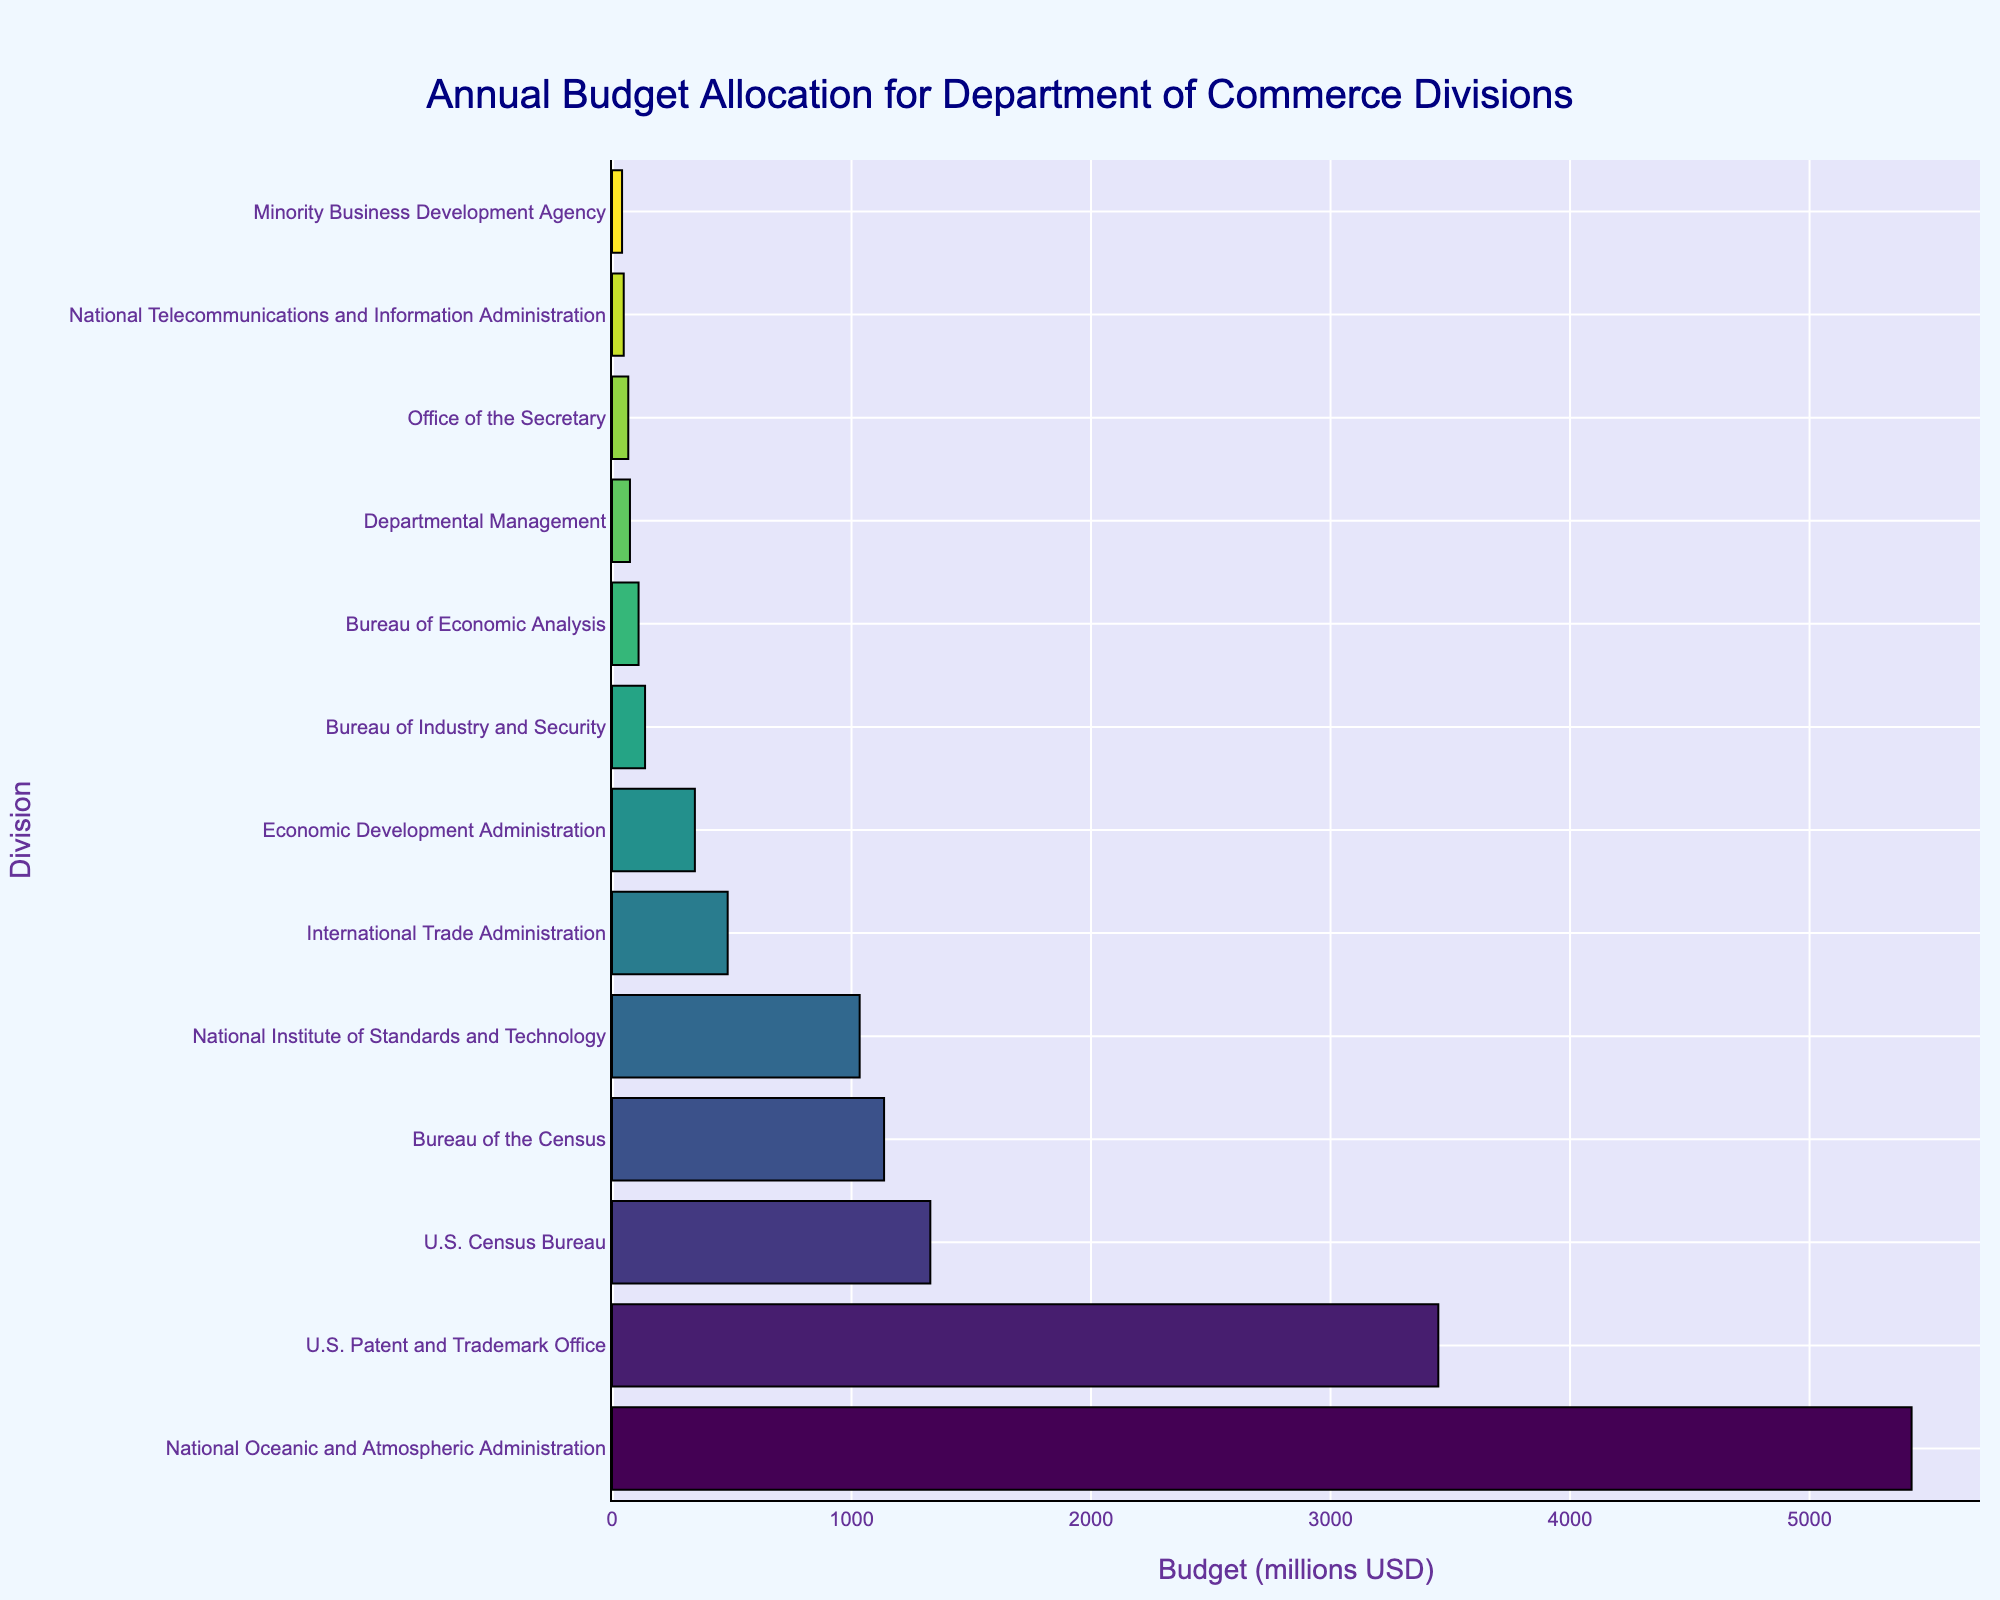Which Division has the highest budget allocation? The Division with the highest budget allocation is the one with the longest bar in the chart. From the bar chart, the National Oceanic and Atmospheric Administration has the longest bar.
Answer: National Oceanic and Atmospheric Administration Which Division has the lowest budget allocation? The Division with the lowest budget allocation has the shortest bar in the chart. From the bar chart, the Minority Business Development Agency has the shortest bar.
Answer: Minority Business Development Agency What is the total budget allocation for the top three Divisions? To find the total budget allocation for the top three Divisions, we need to sum their budget values. The top three Divisions are the National Oceanic and Atmospheric Administration ($5426 million), U.S. Patent and Trademark Office ($3450 million), and U.S. Census Bureau ($1329 million). Therefore, the total is 5426 + 3450 + 1329 = 10205 million USD.
Answer: 10205 million USD How much more budget does the U.S. Patent and Trademark Office have compared to the International Trade Administration? To find how much more budget one Division has compared to another, we subtract the smaller budget from the larger budget. The U.S. Patent and Trademark Office has a budget of $3450 million and the International Trade Administration has a budget of $483 million. Thus, 3450 - 483 = 2967 million USD.
Answer: 2967 million USD What is the average budget allocation of all the Divisions combined? To find the average budget allocation, sum the budgets of all Divisions and divide by the number of Divisions. The total budget allocation is 13199 million USD (sum of all the budgets in the list). There are 13 Divisions, so the average budget is 13199 / 13 ≈ 1015.31 million USD.
Answer: 1015.31 million USD Which Division receives a budget closest to the average budget allocation? First, determine the average budget allocation (1015.31 million USD). Then find the Division with the budget closest to this value. The National Institute of Standards and Technology has a budget of $1034 million, which is closest to the average.
Answer: National Institute of Standards and Technology Is the budget allocation for the U.S. Census Bureau greater than twice the budget of the Bureau of Industry and Security? Double the budget of the Bureau of Industry and Security is 2 * 138 = 276 million USD. The U.S. Census Bureau's budget is $1329 million, which is greater than 276 million USD.
Answer: Yes Which Division has a budget between $300 million and $1000 million? To find this, look at the bars that fall between these amounts. The Economic Development Administration ($346 million), the Bureau of Industry and Security ($138 million), and the National Institute of Standards and Technology ($1034 million) are in the specified range. Hence, only Economic Development Administration is within the range.
Answer: Economic Development Administration How does the budget allocation for the Departmental Management compare to that of the Office of the Secretary? The Departmental Management budget is $75 million, and the Office of the Secretary budget is $68 million. Departmental Management has a slightly higher budget than the Office of the Secretary.
Answer: Departmental Management has a higher budget What is the difference in budget allocation between the U.S. Census Bureau and the Bureau of the Census? The U.S. Census Bureau has a budget of $1329 million, and the Bureau of the Census has a budget of $1136 million. The difference is 1329 - 1136 = 193 million USD.
Answer: 193 million USD 